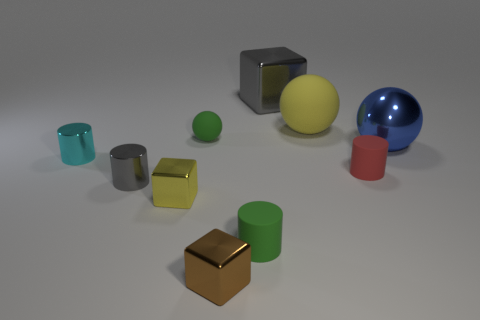How many objects are either large blue things or tiny shiny objects left of the big yellow matte thing?
Give a very brief answer. 5. The gray thing that is on the left side of the green rubber object that is behind the metal object that is to the right of the big gray thing is made of what material?
Your answer should be very brief. Metal. What size is the red cylinder that is the same material as the green cylinder?
Offer a terse response. Small. There is a tiny rubber cylinder that is behind the green object that is to the right of the tiny rubber ball; what is its color?
Your answer should be very brief. Red. What number of red cylinders are the same material as the yellow ball?
Make the answer very short. 1. How many matte things are either cyan things or large blue cylinders?
Offer a terse response. 0. What material is the ball that is the same size as the yellow metal cube?
Your response must be concise. Rubber. Is there a green cylinder made of the same material as the big yellow object?
Give a very brief answer. Yes. There is a large metallic object that is on the left side of the yellow thing that is behind the large metal thing that is on the right side of the red matte cylinder; what shape is it?
Make the answer very short. Cube. Do the green sphere and the yellow object behind the metal ball have the same size?
Your answer should be compact. No. 